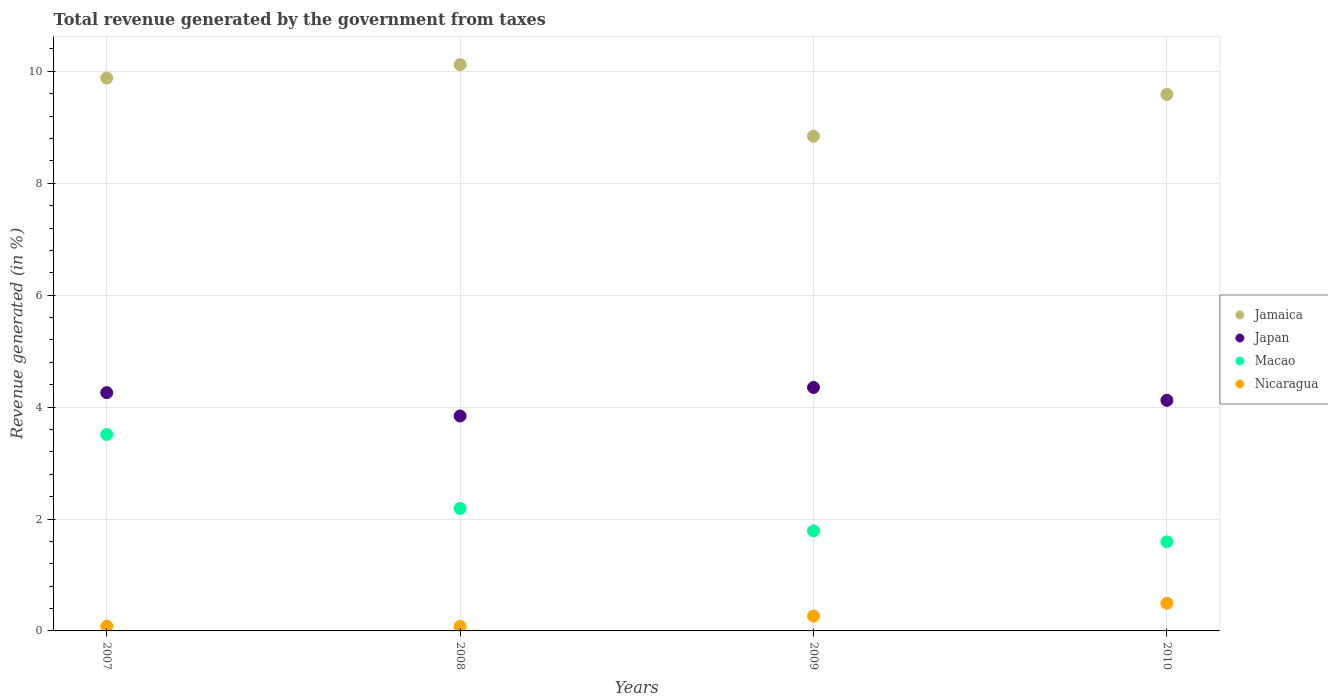How many different coloured dotlines are there?
Offer a very short reply. 4. Is the number of dotlines equal to the number of legend labels?
Offer a very short reply. Yes. What is the total revenue generated in Nicaragua in 2009?
Your answer should be very brief. 0.27. Across all years, what is the maximum total revenue generated in Japan?
Offer a terse response. 4.35. Across all years, what is the minimum total revenue generated in Japan?
Keep it short and to the point. 3.84. In which year was the total revenue generated in Macao maximum?
Give a very brief answer. 2007. What is the total total revenue generated in Nicaragua in the graph?
Keep it short and to the point. 0.92. What is the difference between the total revenue generated in Jamaica in 2007 and that in 2009?
Make the answer very short. 1.04. What is the difference between the total revenue generated in Jamaica in 2009 and the total revenue generated in Japan in 2010?
Your answer should be compact. 4.72. What is the average total revenue generated in Jamaica per year?
Offer a very short reply. 9.61. In the year 2010, what is the difference between the total revenue generated in Macao and total revenue generated in Japan?
Your answer should be compact. -2.53. What is the ratio of the total revenue generated in Macao in 2008 to that in 2010?
Make the answer very short. 1.37. Is the total revenue generated in Jamaica in 2007 less than that in 2008?
Make the answer very short. Yes. What is the difference between the highest and the second highest total revenue generated in Macao?
Your answer should be compact. 1.32. What is the difference between the highest and the lowest total revenue generated in Macao?
Ensure brevity in your answer.  1.92. In how many years, is the total revenue generated in Jamaica greater than the average total revenue generated in Jamaica taken over all years?
Provide a succinct answer. 2. Is the sum of the total revenue generated in Macao in 2007 and 2009 greater than the maximum total revenue generated in Japan across all years?
Ensure brevity in your answer.  Yes. Does the total revenue generated in Macao monotonically increase over the years?
Your answer should be very brief. No. How many dotlines are there?
Your answer should be compact. 4. How many years are there in the graph?
Your answer should be compact. 4. What is the difference between two consecutive major ticks on the Y-axis?
Keep it short and to the point. 2. Does the graph contain grids?
Give a very brief answer. Yes. How many legend labels are there?
Offer a very short reply. 4. What is the title of the graph?
Make the answer very short. Total revenue generated by the government from taxes. What is the label or title of the Y-axis?
Your response must be concise. Revenue generated (in %). What is the Revenue generated (in %) of Jamaica in 2007?
Make the answer very short. 9.88. What is the Revenue generated (in %) of Japan in 2007?
Offer a very short reply. 4.26. What is the Revenue generated (in %) of Macao in 2007?
Give a very brief answer. 3.51. What is the Revenue generated (in %) of Nicaragua in 2007?
Offer a very short reply. 0.08. What is the Revenue generated (in %) in Jamaica in 2008?
Give a very brief answer. 10.12. What is the Revenue generated (in %) in Japan in 2008?
Provide a succinct answer. 3.84. What is the Revenue generated (in %) of Macao in 2008?
Provide a succinct answer. 2.19. What is the Revenue generated (in %) of Nicaragua in 2008?
Provide a succinct answer. 0.08. What is the Revenue generated (in %) in Jamaica in 2009?
Give a very brief answer. 8.84. What is the Revenue generated (in %) in Japan in 2009?
Offer a very short reply. 4.35. What is the Revenue generated (in %) of Macao in 2009?
Keep it short and to the point. 1.79. What is the Revenue generated (in %) in Nicaragua in 2009?
Provide a short and direct response. 0.27. What is the Revenue generated (in %) in Jamaica in 2010?
Provide a succinct answer. 9.59. What is the Revenue generated (in %) of Japan in 2010?
Your answer should be very brief. 4.12. What is the Revenue generated (in %) of Macao in 2010?
Provide a short and direct response. 1.59. What is the Revenue generated (in %) in Nicaragua in 2010?
Ensure brevity in your answer.  0.49. Across all years, what is the maximum Revenue generated (in %) in Jamaica?
Provide a succinct answer. 10.12. Across all years, what is the maximum Revenue generated (in %) in Japan?
Your answer should be compact. 4.35. Across all years, what is the maximum Revenue generated (in %) of Macao?
Your answer should be very brief. 3.51. Across all years, what is the maximum Revenue generated (in %) of Nicaragua?
Keep it short and to the point. 0.49. Across all years, what is the minimum Revenue generated (in %) of Jamaica?
Make the answer very short. 8.84. Across all years, what is the minimum Revenue generated (in %) in Japan?
Your answer should be compact. 3.84. Across all years, what is the minimum Revenue generated (in %) in Macao?
Your answer should be compact. 1.59. Across all years, what is the minimum Revenue generated (in %) of Nicaragua?
Your response must be concise. 0.08. What is the total Revenue generated (in %) in Jamaica in the graph?
Your answer should be compact. 38.43. What is the total Revenue generated (in %) of Japan in the graph?
Your response must be concise. 16.57. What is the total Revenue generated (in %) of Macao in the graph?
Your response must be concise. 9.08. What is the total Revenue generated (in %) in Nicaragua in the graph?
Offer a terse response. 0.92. What is the difference between the Revenue generated (in %) in Jamaica in 2007 and that in 2008?
Provide a short and direct response. -0.24. What is the difference between the Revenue generated (in %) of Japan in 2007 and that in 2008?
Provide a succinct answer. 0.42. What is the difference between the Revenue generated (in %) of Macao in 2007 and that in 2008?
Provide a succinct answer. 1.32. What is the difference between the Revenue generated (in %) in Nicaragua in 2007 and that in 2008?
Provide a succinct answer. 0. What is the difference between the Revenue generated (in %) in Jamaica in 2007 and that in 2009?
Offer a terse response. 1.04. What is the difference between the Revenue generated (in %) of Japan in 2007 and that in 2009?
Provide a succinct answer. -0.09. What is the difference between the Revenue generated (in %) of Macao in 2007 and that in 2009?
Provide a short and direct response. 1.72. What is the difference between the Revenue generated (in %) of Nicaragua in 2007 and that in 2009?
Your response must be concise. -0.18. What is the difference between the Revenue generated (in %) in Jamaica in 2007 and that in 2010?
Your answer should be compact. 0.29. What is the difference between the Revenue generated (in %) of Japan in 2007 and that in 2010?
Provide a short and direct response. 0.14. What is the difference between the Revenue generated (in %) in Macao in 2007 and that in 2010?
Provide a succinct answer. 1.92. What is the difference between the Revenue generated (in %) of Nicaragua in 2007 and that in 2010?
Give a very brief answer. -0.41. What is the difference between the Revenue generated (in %) of Jamaica in 2008 and that in 2009?
Ensure brevity in your answer.  1.28. What is the difference between the Revenue generated (in %) in Japan in 2008 and that in 2009?
Ensure brevity in your answer.  -0.51. What is the difference between the Revenue generated (in %) of Macao in 2008 and that in 2009?
Your answer should be very brief. 0.4. What is the difference between the Revenue generated (in %) in Nicaragua in 2008 and that in 2009?
Give a very brief answer. -0.19. What is the difference between the Revenue generated (in %) in Jamaica in 2008 and that in 2010?
Make the answer very short. 0.53. What is the difference between the Revenue generated (in %) in Japan in 2008 and that in 2010?
Keep it short and to the point. -0.28. What is the difference between the Revenue generated (in %) in Macao in 2008 and that in 2010?
Give a very brief answer. 0.6. What is the difference between the Revenue generated (in %) of Nicaragua in 2008 and that in 2010?
Your answer should be compact. -0.41. What is the difference between the Revenue generated (in %) in Jamaica in 2009 and that in 2010?
Ensure brevity in your answer.  -0.75. What is the difference between the Revenue generated (in %) of Japan in 2009 and that in 2010?
Your answer should be very brief. 0.23. What is the difference between the Revenue generated (in %) in Macao in 2009 and that in 2010?
Offer a very short reply. 0.2. What is the difference between the Revenue generated (in %) in Nicaragua in 2009 and that in 2010?
Provide a short and direct response. -0.23. What is the difference between the Revenue generated (in %) of Jamaica in 2007 and the Revenue generated (in %) of Japan in 2008?
Give a very brief answer. 6.04. What is the difference between the Revenue generated (in %) in Jamaica in 2007 and the Revenue generated (in %) in Macao in 2008?
Ensure brevity in your answer.  7.69. What is the difference between the Revenue generated (in %) of Jamaica in 2007 and the Revenue generated (in %) of Nicaragua in 2008?
Provide a short and direct response. 9.8. What is the difference between the Revenue generated (in %) in Japan in 2007 and the Revenue generated (in %) in Macao in 2008?
Your answer should be very brief. 2.07. What is the difference between the Revenue generated (in %) of Japan in 2007 and the Revenue generated (in %) of Nicaragua in 2008?
Provide a succinct answer. 4.18. What is the difference between the Revenue generated (in %) in Macao in 2007 and the Revenue generated (in %) in Nicaragua in 2008?
Offer a terse response. 3.43. What is the difference between the Revenue generated (in %) in Jamaica in 2007 and the Revenue generated (in %) in Japan in 2009?
Keep it short and to the point. 5.53. What is the difference between the Revenue generated (in %) in Jamaica in 2007 and the Revenue generated (in %) in Macao in 2009?
Keep it short and to the point. 8.09. What is the difference between the Revenue generated (in %) in Jamaica in 2007 and the Revenue generated (in %) in Nicaragua in 2009?
Give a very brief answer. 9.62. What is the difference between the Revenue generated (in %) of Japan in 2007 and the Revenue generated (in %) of Macao in 2009?
Your response must be concise. 2.47. What is the difference between the Revenue generated (in %) in Japan in 2007 and the Revenue generated (in %) in Nicaragua in 2009?
Make the answer very short. 3.99. What is the difference between the Revenue generated (in %) in Macao in 2007 and the Revenue generated (in %) in Nicaragua in 2009?
Give a very brief answer. 3.25. What is the difference between the Revenue generated (in %) of Jamaica in 2007 and the Revenue generated (in %) of Japan in 2010?
Keep it short and to the point. 5.76. What is the difference between the Revenue generated (in %) in Jamaica in 2007 and the Revenue generated (in %) in Macao in 2010?
Keep it short and to the point. 8.29. What is the difference between the Revenue generated (in %) of Jamaica in 2007 and the Revenue generated (in %) of Nicaragua in 2010?
Your answer should be very brief. 9.39. What is the difference between the Revenue generated (in %) in Japan in 2007 and the Revenue generated (in %) in Macao in 2010?
Ensure brevity in your answer.  2.67. What is the difference between the Revenue generated (in %) in Japan in 2007 and the Revenue generated (in %) in Nicaragua in 2010?
Provide a short and direct response. 3.76. What is the difference between the Revenue generated (in %) of Macao in 2007 and the Revenue generated (in %) of Nicaragua in 2010?
Provide a short and direct response. 3.02. What is the difference between the Revenue generated (in %) of Jamaica in 2008 and the Revenue generated (in %) of Japan in 2009?
Keep it short and to the point. 5.77. What is the difference between the Revenue generated (in %) of Jamaica in 2008 and the Revenue generated (in %) of Macao in 2009?
Make the answer very short. 8.33. What is the difference between the Revenue generated (in %) of Jamaica in 2008 and the Revenue generated (in %) of Nicaragua in 2009?
Provide a short and direct response. 9.85. What is the difference between the Revenue generated (in %) in Japan in 2008 and the Revenue generated (in %) in Macao in 2009?
Keep it short and to the point. 2.05. What is the difference between the Revenue generated (in %) in Japan in 2008 and the Revenue generated (in %) in Nicaragua in 2009?
Your response must be concise. 3.58. What is the difference between the Revenue generated (in %) in Macao in 2008 and the Revenue generated (in %) in Nicaragua in 2009?
Ensure brevity in your answer.  1.92. What is the difference between the Revenue generated (in %) of Jamaica in 2008 and the Revenue generated (in %) of Japan in 2010?
Provide a short and direct response. 6. What is the difference between the Revenue generated (in %) in Jamaica in 2008 and the Revenue generated (in %) in Macao in 2010?
Give a very brief answer. 8.53. What is the difference between the Revenue generated (in %) of Jamaica in 2008 and the Revenue generated (in %) of Nicaragua in 2010?
Your answer should be compact. 9.62. What is the difference between the Revenue generated (in %) in Japan in 2008 and the Revenue generated (in %) in Macao in 2010?
Provide a succinct answer. 2.25. What is the difference between the Revenue generated (in %) of Japan in 2008 and the Revenue generated (in %) of Nicaragua in 2010?
Provide a short and direct response. 3.35. What is the difference between the Revenue generated (in %) in Macao in 2008 and the Revenue generated (in %) in Nicaragua in 2010?
Offer a terse response. 1.69. What is the difference between the Revenue generated (in %) in Jamaica in 2009 and the Revenue generated (in %) in Japan in 2010?
Give a very brief answer. 4.72. What is the difference between the Revenue generated (in %) in Jamaica in 2009 and the Revenue generated (in %) in Macao in 2010?
Make the answer very short. 7.25. What is the difference between the Revenue generated (in %) in Jamaica in 2009 and the Revenue generated (in %) in Nicaragua in 2010?
Make the answer very short. 8.35. What is the difference between the Revenue generated (in %) of Japan in 2009 and the Revenue generated (in %) of Macao in 2010?
Ensure brevity in your answer.  2.76. What is the difference between the Revenue generated (in %) in Japan in 2009 and the Revenue generated (in %) in Nicaragua in 2010?
Give a very brief answer. 3.86. What is the difference between the Revenue generated (in %) in Macao in 2009 and the Revenue generated (in %) in Nicaragua in 2010?
Provide a succinct answer. 1.29. What is the average Revenue generated (in %) in Jamaica per year?
Offer a very short reply. 9.61. What is the average Revenue generated (in %) in Japan per year?
Keep it short and to the point. 4.14. What is the average Revenue generated (in %) of Macao per year?
Offer a terse response. 2.27. What is the average Revenue generated (in %) of Nicaragua per year?
Provide a short and direct response. 0.23. In the year 2007, what is the difference between the Revenue generated (in %) in Jamaica and Revenue generated (in %) in Japan?
Provide a succinct answer. 5.62. In the year 2007, what is the difference between the Revenue generated (in %) of Jamaica and Revenue generated (in %) of Macao?
Your answer should be compact. 6.37. In the year 2007, what is the difference between the Revenue generated (in %) in Jamaica and Revenue generated (in %) in Nicaragua?
Ensure brevity in your answer.  9.8. In the year 2007, what is the difference between the Revenue generated (in %) in Japan and Revenue generated (in %) in Macao?
Offer a terse response. 0.75. In the year 2007, what is the difference between the Revenue generated (in %) in Japan and Revenue generated (in %) in Nicaragua?
Keep it short and to the point. 4.17. In the year 2007, what is the difference between the Revenue generated (in %) in Macao and Revenue generated (in %) in Nicaragua?
Provide a short and direct response. 3.43. In the year 2008, what is the difference between the Revenue generated (in %) of Jamaica and Revenue generated (in %) of Japan?
Make the answer very short. 6.28. In the year 2008, what is the difference between the Revenue generated (in %) of Jamaica and Revenue generated (in %) of Macao?
Your answer should be compact. 7.93. In the year 2008, what is the difference between the Revenue generated (in %) of Jamaica and Revenue generated (in %) of Nicaragua?
Your response must be concise. 10.04. In the year 2008, what is the difference between the Revenue generated (in %) of Japan and Revenue generated (in %) of Macao?
Ensure brevity in your answer.  1.65. In the year 2008, what is the difference between the Revenue generated (in %) in Japan and Revenue generated (in %) in Nicaragua?
Make the answer very short. 3.76. In the year 2008, what is the difference between the Revenue generated (in %) of Macao and Revenue generated (in %) of Nicaragua?
Your answer should be compact. 2.11. In the year 2009, what is the difference between the Revenue generated (in %) in Jamaica and Revenue generated (in %) in Japan?
Offer a very short reply. 4.49. In the year 2009, what is the difference between the Revenue generated (in %) in Jamaica and Revenue generated (in %) in Macao?
Your answer should be compact. 7.05. In the year 2009, what is the difference between the Revenue generated (in %) in Jamaica and Revenue generated (in %) in Nicaragua?
Keep it short and to the point. 8.57. In the year 2009, what is the difference between the Revenue generated (in %) of Japan and Revenue generated (in %) of Macao?
Give a very brief answer. 2.56. In the year 2009, what is the difference between the Revenue generated (in %) of Japan and Revenue generated (in %) of Nicaragua?
Your answer should be compact. 4.09. In the year 2009, what is the difference between the Revenue generated (in %) of Macao and Revenue generated (in %) of Nicaragua?
Your answer should be very brief. 1.52. In the year 2010, what is the difference between the Revenue generated (in %) in Jamaica and Revenue generated (in %) in Japan?
Offer a terse response. 5.47. In the year 2010, what is the difference between the Revenue generated (in %) of Jamaica and Revenue generated (in %) of Macao?
Your answer should be very brief. 8. In the year 2010, what is the difference between the Revenue generated (in %) in Jamaica and Revenue generated (in %) in Nicaragua?
Offer a very short reply. 9.09. In the year 2010, what is the difference between the Revenue generated (in %) of Japan and Revenue generated (in %) of Macao?
Your answer should be compact. 2.53. In the year 2010, what is the difference between the Revenue generated (in %) of Japan and Revenue generated (in %) of Nicaragua?
Provide a short and direct response. 3.63. In the year 2010, what is the difference between the Revenue generated (in %) of Macao and Revenue generated (in %) of Nicaragua?
Make the answer very short. 1.1. What is the ratio of the Revenue generated (in %) in Jamaica in 2007 to that in 2008?
Make the answer very short. 0.98. What is the ratio of the Revenue generated (in %) of Japan in 2007 to that in 2008?
Provide a short and direct response. 1.11. What is the ratio of the Revenue generated (in %) in Macao in 2007 to that in 2008?
Make the answer very short. 1.6. What is the ratio of the Revenue generated (in %) of Nicaragua in 2007 to that in 2008?
Offer a very short reply. 1.06. What is the ratio of the Revenue generated (in %) in Jamaica in 2007 to that in 2009?
Give a very brief answer. 1.12. What is the ratio of the Revenue generated (in %) of Japan in 2007 to that in 2009?
Make the answer very short. 0.98. What is the ratio of the Revenue generated (in %) in Macao in 2007 to that in 2009?
Your response must be concise. 1.96. What is the ratio of the Revenue generated (in %) in Nicaragua in 2007 to that in 2009?
Make the answer very short. 0.32. What is the ratio of the Revenue generated (in %) in Jamaica in 2007 to that in 2010?
Your answer should be compact. 1.03. What is the ratio of the Revenue generated (in %) of Japan in 2007 to that in 2010?
Give a very brief answer. 1.03. What is the ratio of the Revenue generated (in %) in Macao in 2007 to that in 2010?
Your response must be concise. 2.21. What is the ratio of the Revenue generated (in %) of Nicaragua in 2007 to that in 2010?
Keep it short and to the point. 0.17. What is the ratio of the Revenue generated (in %) of Jamaica in 2008 to that in 2009?
Offer a very short reply. 1.14. What is the ratio of the Revenue generated (in %) of Japan in 2008 to that in 2009?
Offer a terse response. 0.88. What is the ratio of the Revenue generated (in %) of Macao in 2008 to that in 2009?
Ensure brevity in your answer.  1.22. What is the ratio of the Revenue generated (in %) in Nicaragua in 2008 to that in 2009?
Your response must be concise. 0.3. What is the ratio of the Revenue generated (in %) of Jamaica in 2008 to that in 2010?
Provide a short and direct response. 1.06. What is the ratio of the Revenue generated (in %) of Japan in 2008 to that in 2010?
Keep it short and to the point. 0.93. What is the ratio of the Revenue generated (in %) of Macao in 2008 to that in 2010?
Keep it short and to the point. 1.37. What is the ratio of the Revenue generated (in %) in Nicaragua in 2008 to that in 2010?
Offer a terse response. 0.16. What is the ratio of the Revenue generated (in %) in Jamaica in 2009 to that in 2010?
Your answer should be very brief. 0.92. What is the ratio of the Revenue generated (in %) in Japan in 2009 to that in 2010?
Your response must be concise. 1.06. What is the ratio of the Revenue generated (in %) in Macao in 2009 to that in 2010?
Your answer should be very brief. 1.12. What is the ratio of the Revenue generated (in %) in Nicaragua in 2009 to that in 2010?
Your answer should be very brief. 0.54. What is the difference between the highest and the second highest Revenue generated (in %) in Jamaica?
Keep it short and to the point. 0.24. What is the difference between the highest and the second highest Revenue generated (in %) of Japan?
Give a very brief answer. 0.09. What is the difference between the highest and the second highest Revenue generated (in %) in Macao?
Provide a succinct answer. 1.32. What is the difference between the highest and the second highest Revenue generated (in %) in Nicaragua?
Your answer should be very brief. 0.23. What is the difference between the highest and the lowest Revenue generated (in %) of Jamaica?
Give a very brief answer. 1.28. What is the difference between the highest and the lowest Revenue generated (in %) in Japan?
Give a very brief answer. 0.51. What is the difference between the highest and the lowest Revenue generated (in %) in Macao?
Ensure brevity in your answer.  1.92. What is the difference between the highest and the lowest Revenue generated (in %) in Nicaragua?
Your response must be concise. 0.41. 